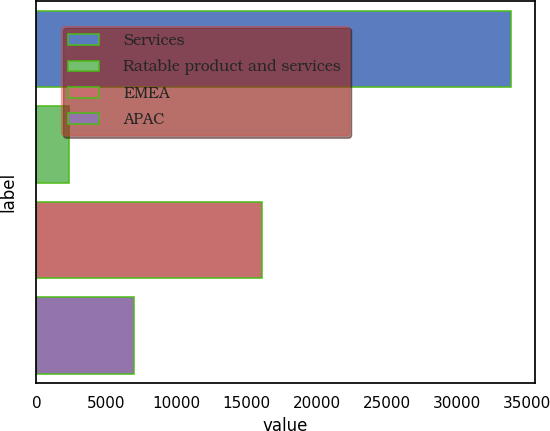Convert chart to OTSL. <chart><loc_0><loc_0><loc_500><loc_500><bar_chart><fcel>Services<fcel>Ratable product and services<fcel>EMEA<fcel>APAC<nl><fcel>33880<fcel>2345<fcel>16131<fcel>6939<nl></chart> 